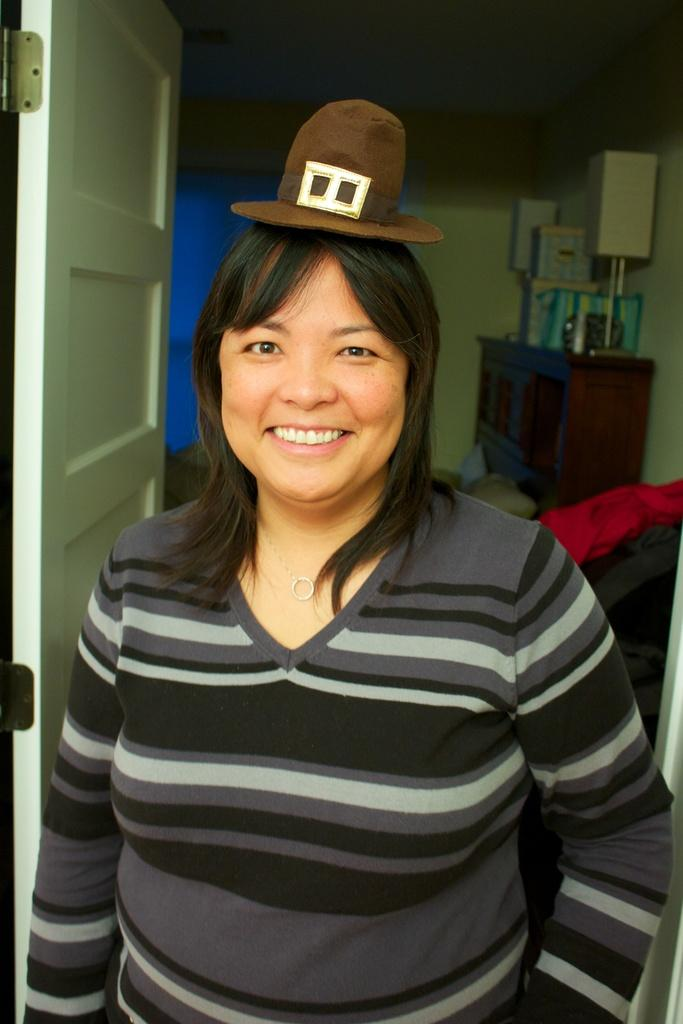Who is present in the image? There is a woman in the image. What is the woman's expression? The woman is smiling. What can be seen in the background of the image? There is a door, a wall, and other objects in the image. What is the woman holding in the image? The woman is holding a hat and cloth in the image. What type of furniture is present in the image? There is a table in the image. What type of shoe is the police officer wearing in the image? There is no police officer or shoe present in the image. What type of coat is the woman wearing in the image? The image does not show the woman wearing a coat. 